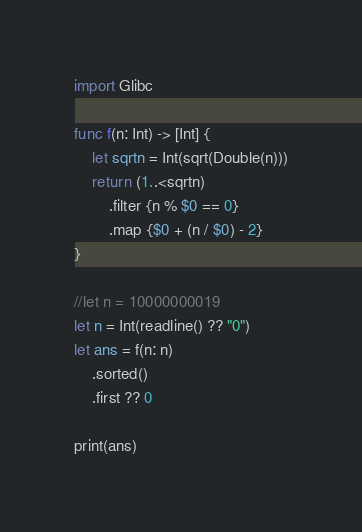Convert code to text. <code><loc_0><loc_0><loc_500><loc_500><_Swift_>import Glibc

func f(n: Int) -> [Int] {
    let sqrtn = Int(sqrt(Double(n)))
    return (1..<sqrtn)
        .filter {n % $0 == 0}
        .map {$0 + (n / $0) - 2}
}

//let n = 10000000019
let n = Int(readline() ?? "0")
let ans = f(n: n)
    .sorted()
    .first ?? 0

print(ans)
</code> 